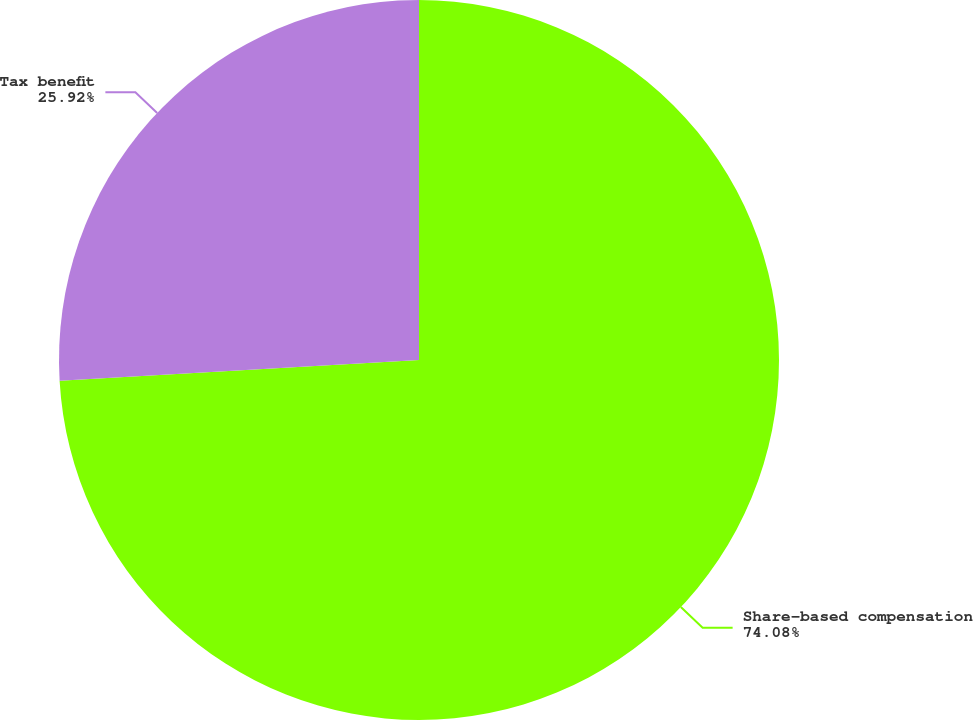Convert chart. <chart><loc_0><loc_0><loc_500><loc_500><pie_chart><fcel>Share-based compensation<fcel>Tax benefit<nl><fcel>74.08%<fcel>25.92%<nl></chart> 